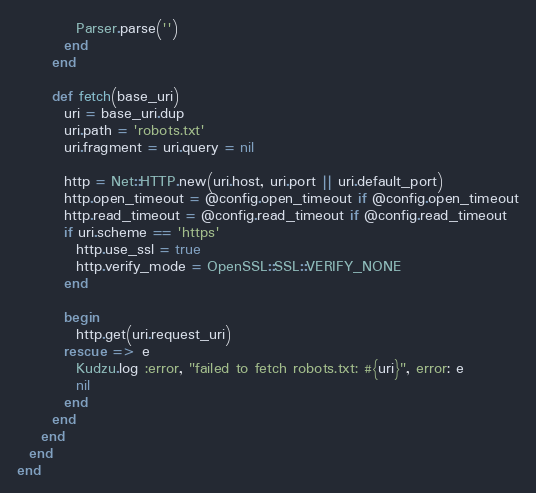Convert code to text. <code><loc_0><loc_0><loc_500><loc_500><_Ruby_>          Parser.parse('')
        end
      end

      def fetch(base_uri)
        uri = base_uri.dup
        uri.path = 'robots.txt'
        uri.fragment = uri.query = nil

        http = Net::HTTP.new(uri.host, uri.port || uri.default_port)
        http.open_timeout = @config.open_timeout if @config.open_timeout
        http.read_timeout = @config.read_timeout if @config.read_timeout
        if uri.scheme == 'https'
          http.use_ssl = true
          http.verify_mode = OpenSSL::SSL::VERIFY_NONE
        end

        begin
          http.get(uri.request_uri)
        rescue => e
          Kudzu.log :error, "failed to fetch robots.txt: #{uri}", error: e
          nil
        end
      end
    end
  end
end
</code> 